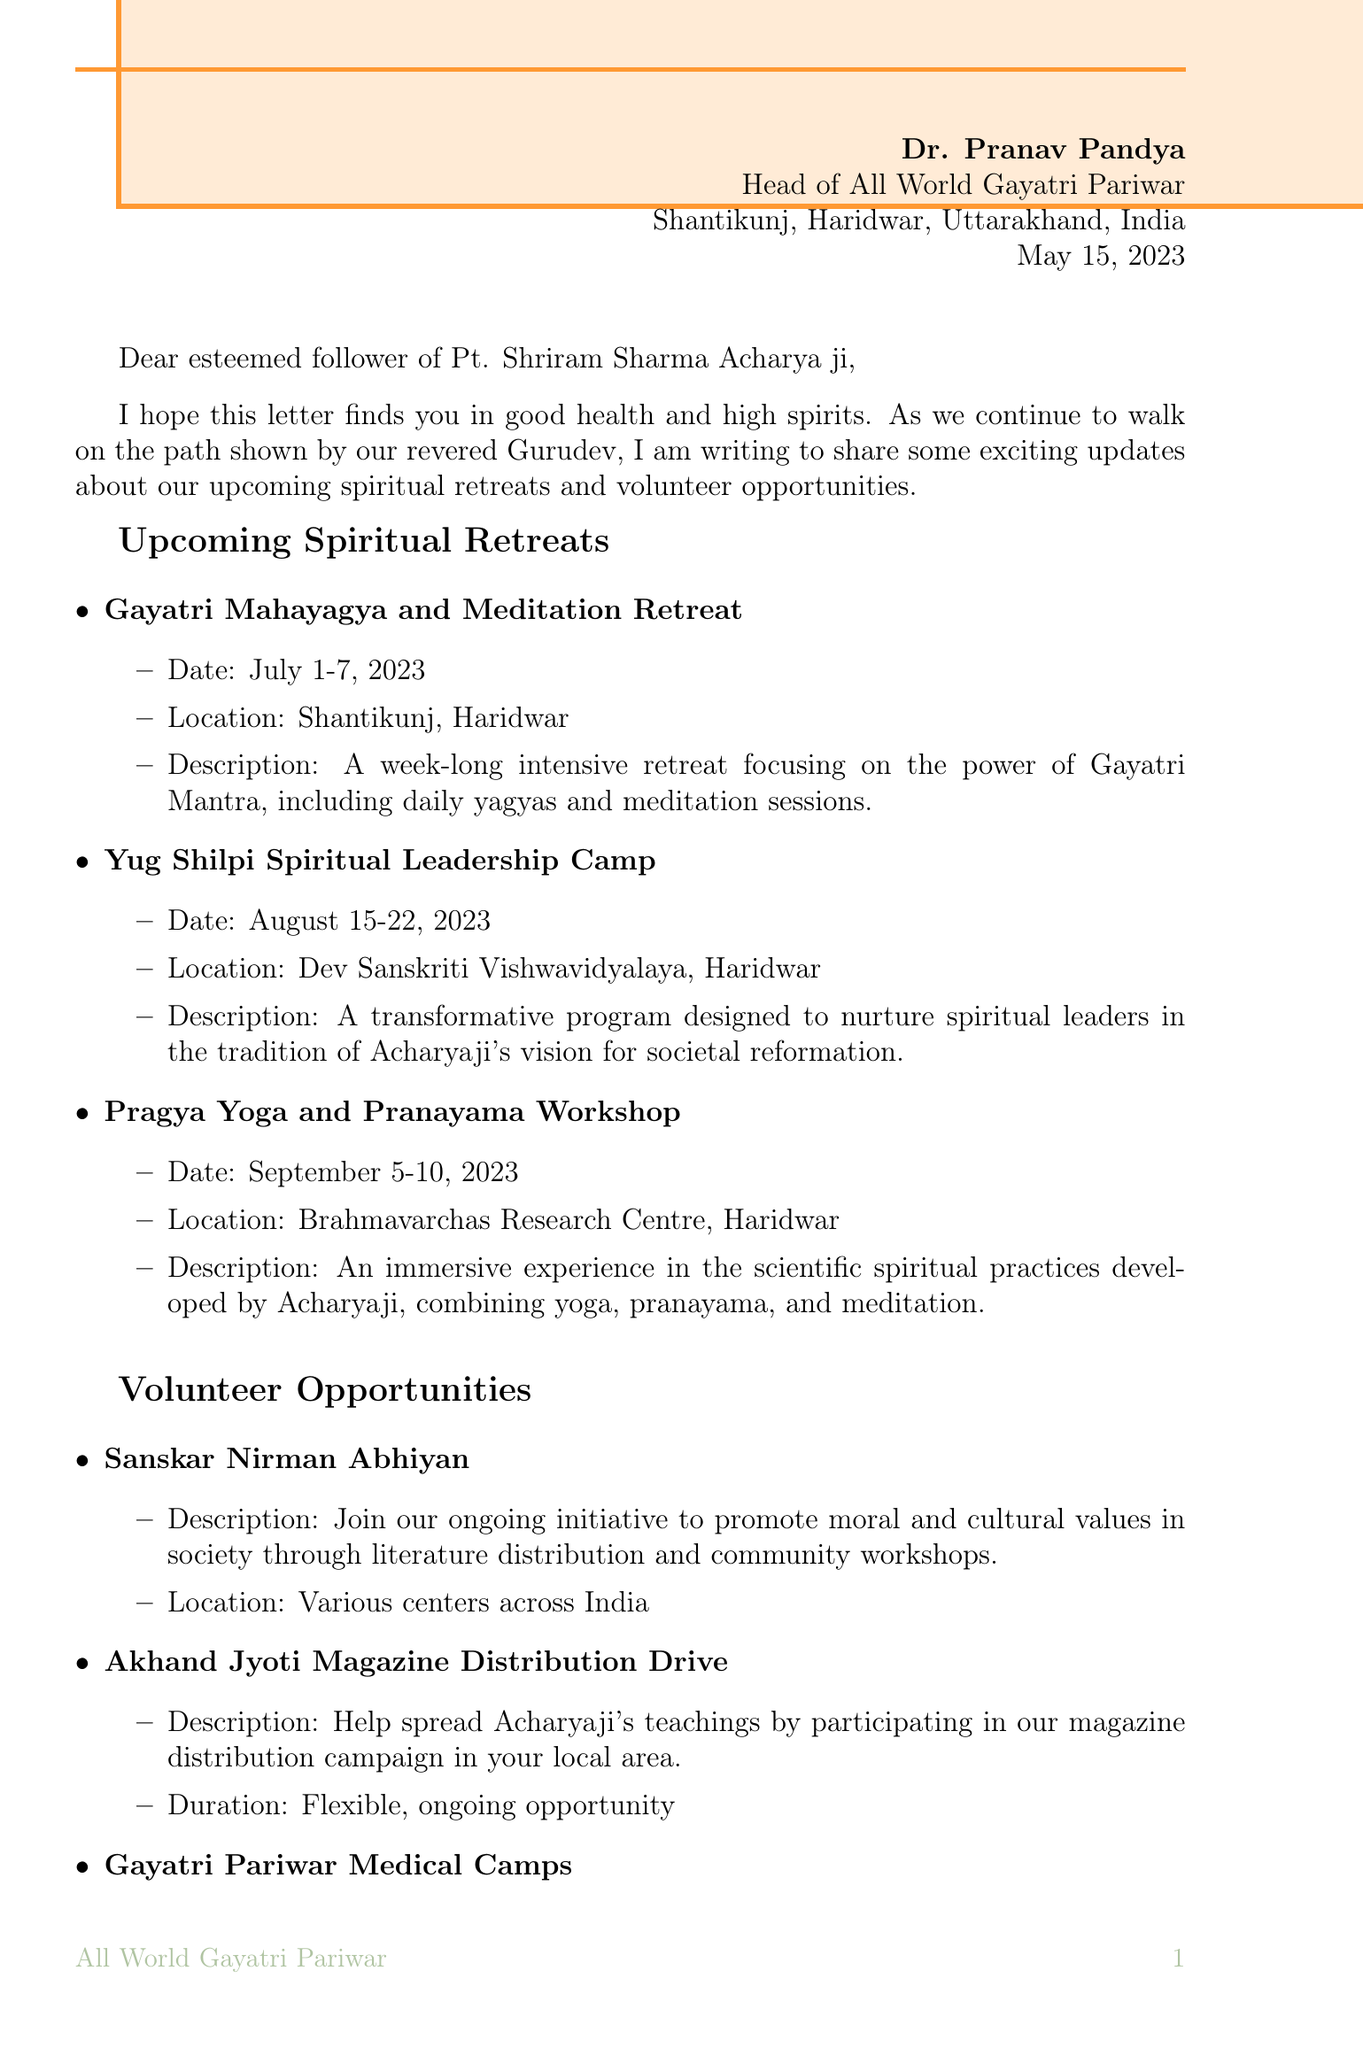What is the sender's name? The sender's name is mentioned in the letter header.
Answer: Dr. Pranav Pandya What is the date of the letter? The date is given in the letter header section.
Answer: May 15, 2023 What is the location of the Gayatri Mahayagya and Meditation Retreat? The location is specified under the spiritual retreats section.
Answer: Shantikunj, Haridwar When does the Yug Shilpi Spiritual Leadership Camp occur? The date is provided in the details of the spiritual retreats.
Answer: August 15-22, 2023 What is the purpose of the Sanskar Nirman Abhiyan? The document explains the initiative's goal in the volunteer opportunities section.
Answer: Promote moral and cultural values What is required to participate in the Akhand Jyoti Magazine Distribution Drive? The document mentions this campaign under volunteer opportunities.
Answer: Ongoing opportunity How often do the Gayatri Pariwar Medical Camps take place? The document specifies the frequency of these camps in the volunteer opportunities section.
Answer: Monthly What is a key teaching of Acharyaji mentioned in the letter? The letter includes several teachings under a specific section.
Answer: The greatest service to humanity is to awaken the divine consciousness within each individual What should one do for more information or registration? The document provides explicit instructions in the closing paragraph and postscript.
Answer: Visit our website www.awgp.org 